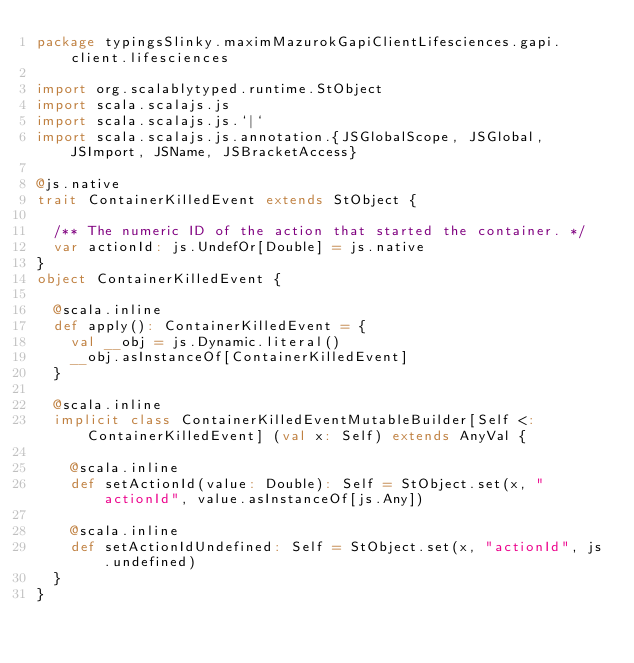Convert code to text. <code><loc_0><loc_0><loc_500><loc_500><_Scala_>package typingsSlinky.maximMazurokGapiClientLifesciences.gapi.client.lifesciences

import org.scalablytyped.runtime.StObject
import scala.scalajs.js
import scala.scalajs.js.`|`
import scala.scalajs.js.annotation.{JSGlobalScope, JSGlobal, JSImport, JSName, JSBracketAccess}

@js.native
trait ContainerKilledEvent extends StObject {
  
  /** The numeric ID of the action that started the container. */
  var actionId: js.UndefOr[Double] = js.native
}
object ContainerKilledEvent {
  
  @scala.inline
  def apply(): ContainerKilledEvent = {
    val __obj = js.Dynamic.literal()
    __obj.asInstanceOf[ContainerKilledEvent]
  }
  
  @scala.inline
  implicit class ContainerKilledEventMutableBuilder[Self <: ContainerKilledEvent] (val x: Self) extends AnyVal {
    
    @scala.inline
    def setActionId(value: Double): Self = StObject.set(x, "actionId", value.asInstanceOf[js.Any])
    
    @scala.inline
    def setActionIdUndefined: Self = StObject.set(x, "actionId", js.undefined)
  }
}
</code> 